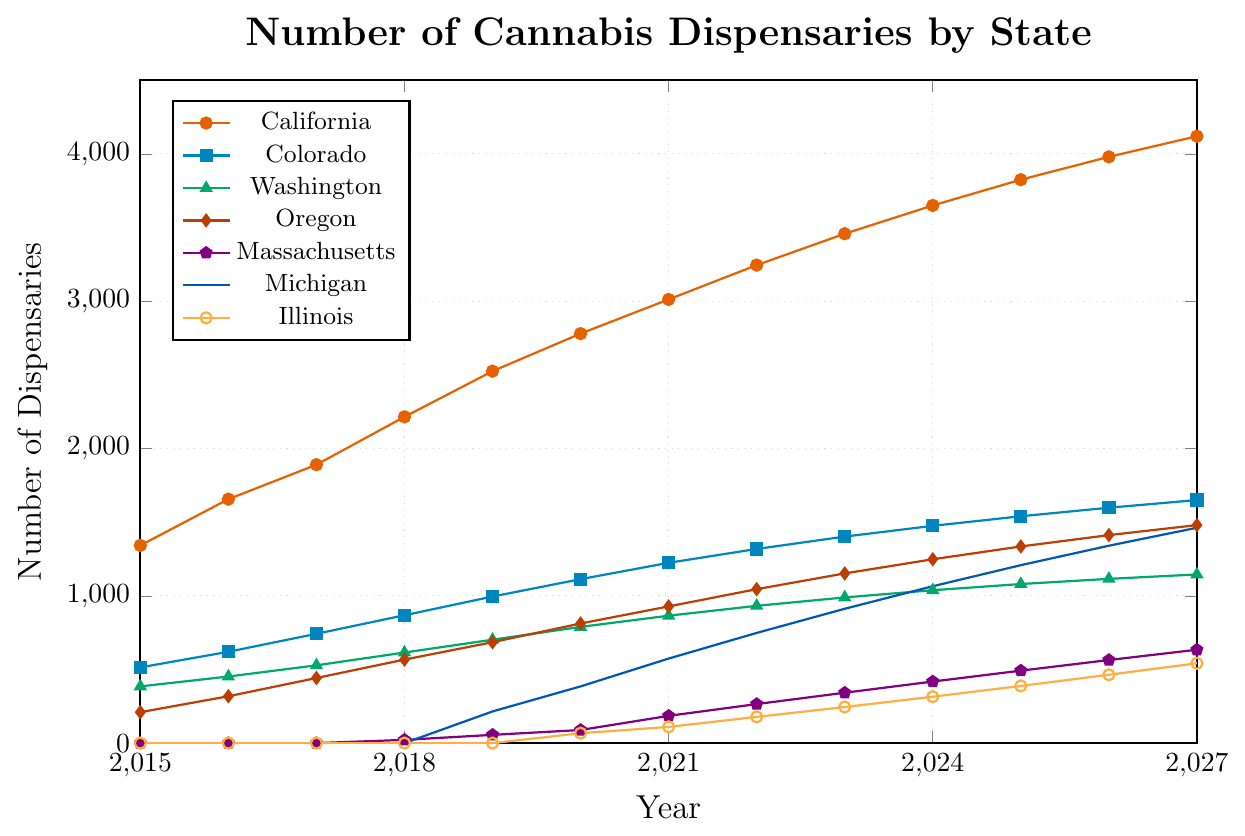How many dispensaries were there in California and Colorado in 2023 combined? In 2023, California had 3458 dispensaries and Colorado had 1402. Adding these together, 3458 + 1402 = 4860.
Answer: 4860 Which state had the most dispensaries opened by 2027? In 2027, California had the most dispensaries with 4120, compared to other states like Colorado with 1650 and Washington with 1145.
Answer: California How does the number of dispensaries in Oregon compare to Massachusetts in 2020? In 2020, Oregon had 812 dispensaries, while Massachusetts had 89. Therefore, Oregon had significantly more dispensaries than Massachusetts.
Answer: Oregon What is the trend in the number of dispensaries in Michigan between 2019 and 2027? From 2019 (215 dispensaries) to 2027 (1462 dispensaries), Michigan saw a steady increase every year, indicating a strong upward trend.
Answer: Upward What is the average number of dispensaries in Illinois from 2020 to 2023? The number of dispensaries in Illinois from 2020 to 2023 were 67, 110, 178, and 245. Adding these and dividing by 4 gives (67 + 110 + 178 + 245) / 4 = 600 / 4 = 150.
Answer: 150 By how much did the number of dispensaries in California increase from 2015 to 2027? In 2015, California had 1342 dispensaries, and by 2027, it had 4120. The increase is 4120 - 1342 = 2778.
Answer: 2778 Which two states show the most potential for growth based on the projected data from 2023 to 2027? Comparing the projected increases from 2023 to 2027, Michigan grows from 912 to 1462 (+550) and Illinois from 245 to 542 (+297), highlighting Michigan and Illinois as states with significant growth potential.
Answer: Michigan and Illinois What color represents Washington in the chart? Washington is represented by a green color in the chart.
Answer: Green In which year did Massachusetts first open dispensaries according to the data? According to the data, Massachusetts first opened dispensaries in 2018.
Answer: 2018 